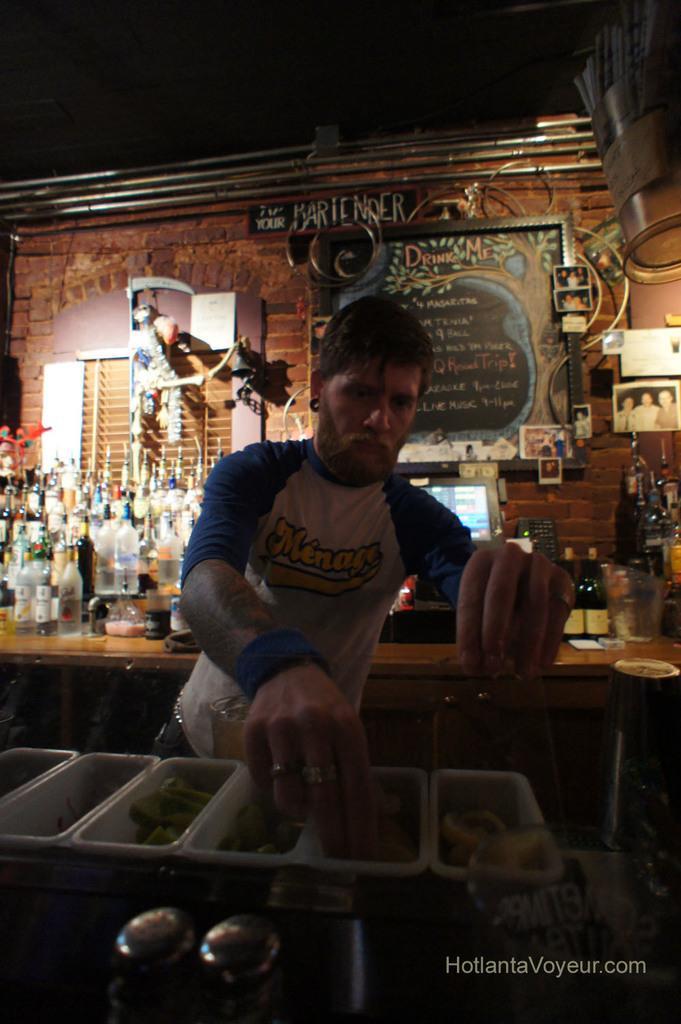In one or two sentences, can you explain what this image depicts? In this image we have a man standing and doing something and at the back ground we have group of bottles in the rack , and board written with some letters , and a light , and picture frames attached to the wall and a computer. 